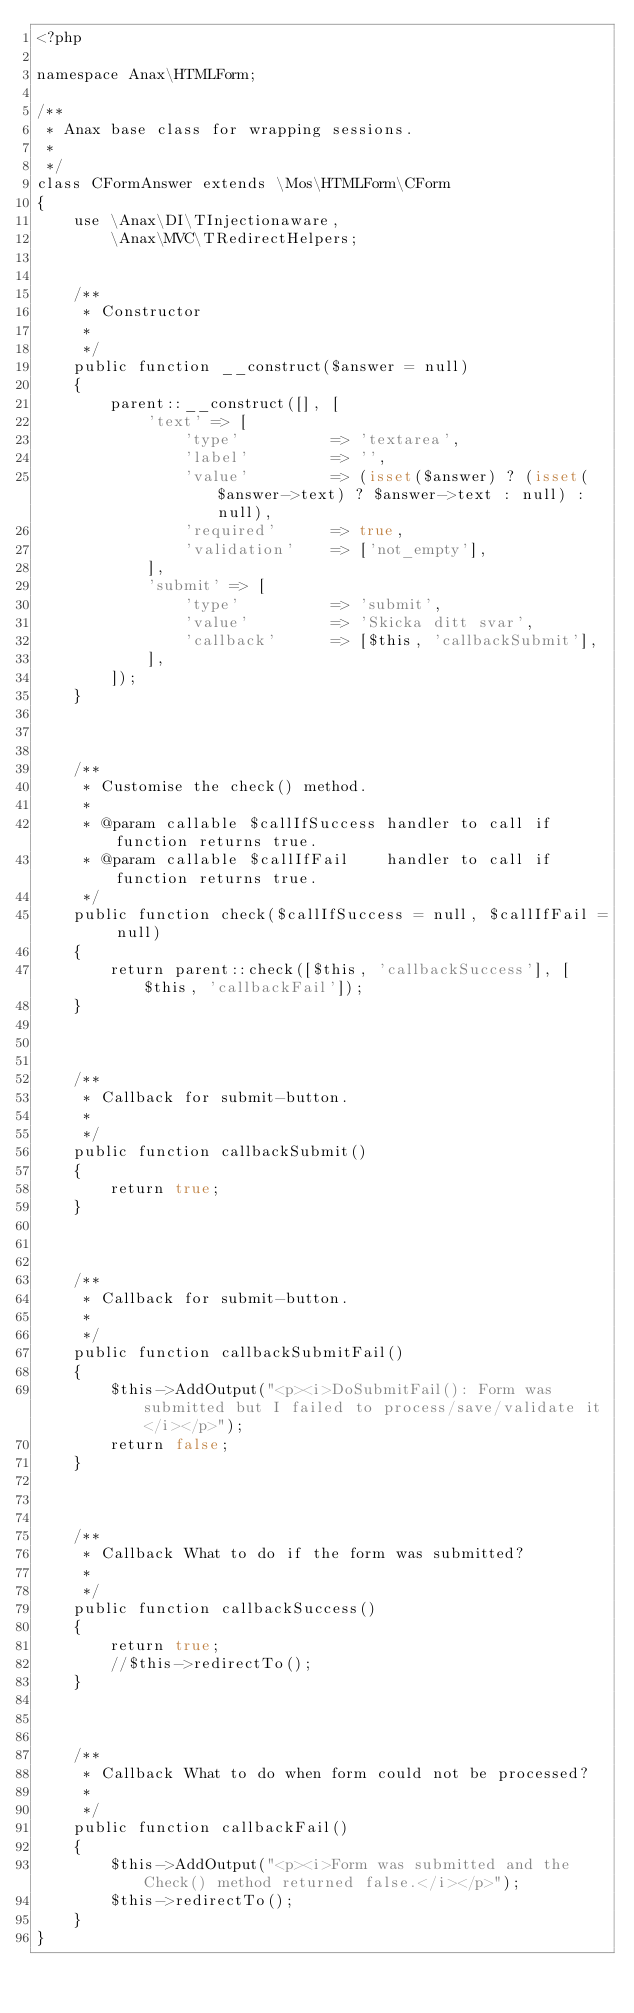Convert code to text. <code><loc_0><loc_0><loc_500><loc_500><_PHP_><?php

namespace Anax\HTMLForm;

/**
 * Anax base class for wrapping sessions.
 *
 */
class CFormAnswer extends \Mos\HTMLForm\CForm
{
    use \Anax\DI\TInjectionaware,
        \Anax\MVC\TRedirectHelpers;


    /**
     * Constructor
     *
     */
    public function __construct($answer = null)
    {
        parent::__construct([], [
            'text' => [
                'type'          => 'textarea',
                'label'         => '',
                'value'         => (isset($answer) ? (isset($answer->text) ? $answer->text : null) : null),
                'required'      => true,
                'validation'    => ['not_empty'],
            ],
            'submit' => [
                'type'          => 'submit',
                'value'         => 'Skicka ditt svar',
                'callback'      => [$this, 'callbackSubmit'],
            ],
        ]);
    }



    /**
     * Customise the check() method.
     *
     * @param callable $callIfSuccess handler to call if function returns true.
     * @param callable $callIfFail    handler to call if function returns true.
     */
    public function check($callIfSuccess = null, $callIfFail = null)
    {
        return parent::check([$this, 'callbackSuccess'], [$this, 'callbackFail']);
    }



    /**
     * Callback for submit-button.
     *
     */
    public function callbackSubmit()
    {
        return true;
    }



    /**
     * Callback for submit-button.
     *
     */
    public function callbackSubmitFail()
    {
        $this->AddOutput("<p><i>DoSubmitFail(): Form was submitted but I failed to process/save/validate it</i></p>");
        return false;
    }



    /**
     * Callback What to do if the form was submitted?
     *
     */
    public function callbackSuccess()
    {
        return true;
        //$this->redirectTo();
    }



    /**
     * Callback What to do when form could not be processed?
     *
     */
    public function callbackFail()
    {   
        $this->AddOutput("<p><i>Form was submitted and the Check() method returned false.</i></p>");
        $this->redirectTo();
    }
}
</code> 